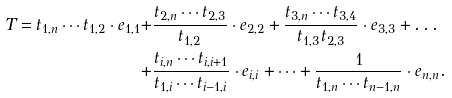<formula> <loc_0><loc_0><loc_500><loc_500>T = t _ { 1 , n } \cdots t _ { 1 , 2 } \cdot e _ { 1 , 1 } + & \frac { t _ { 2 , n } \cdots t _ { 2 , 3 } } { t _ { 1 , 2 } } \cdot e _ { 2 , 2 } + \frac { t _ { 3 , n } \cdots t _ { 3 , 4 } } { t _ { 1 , 3 } t _ { 2 , 3 } } \cdot e _ { 3 , 3 } + \dots \\ + & \frac { t _ { i , n } \cdots t _ { i , i + 1 } } { t _ { 1 , i } \cdots t _ { i - 1 , i } } \cdot e _ { i , i } + \dots + \frac { 1 } { t _ { 1 , n } \cdots t _ { n - 1 , n } } \cdot e _ { n , n } .</formula> 